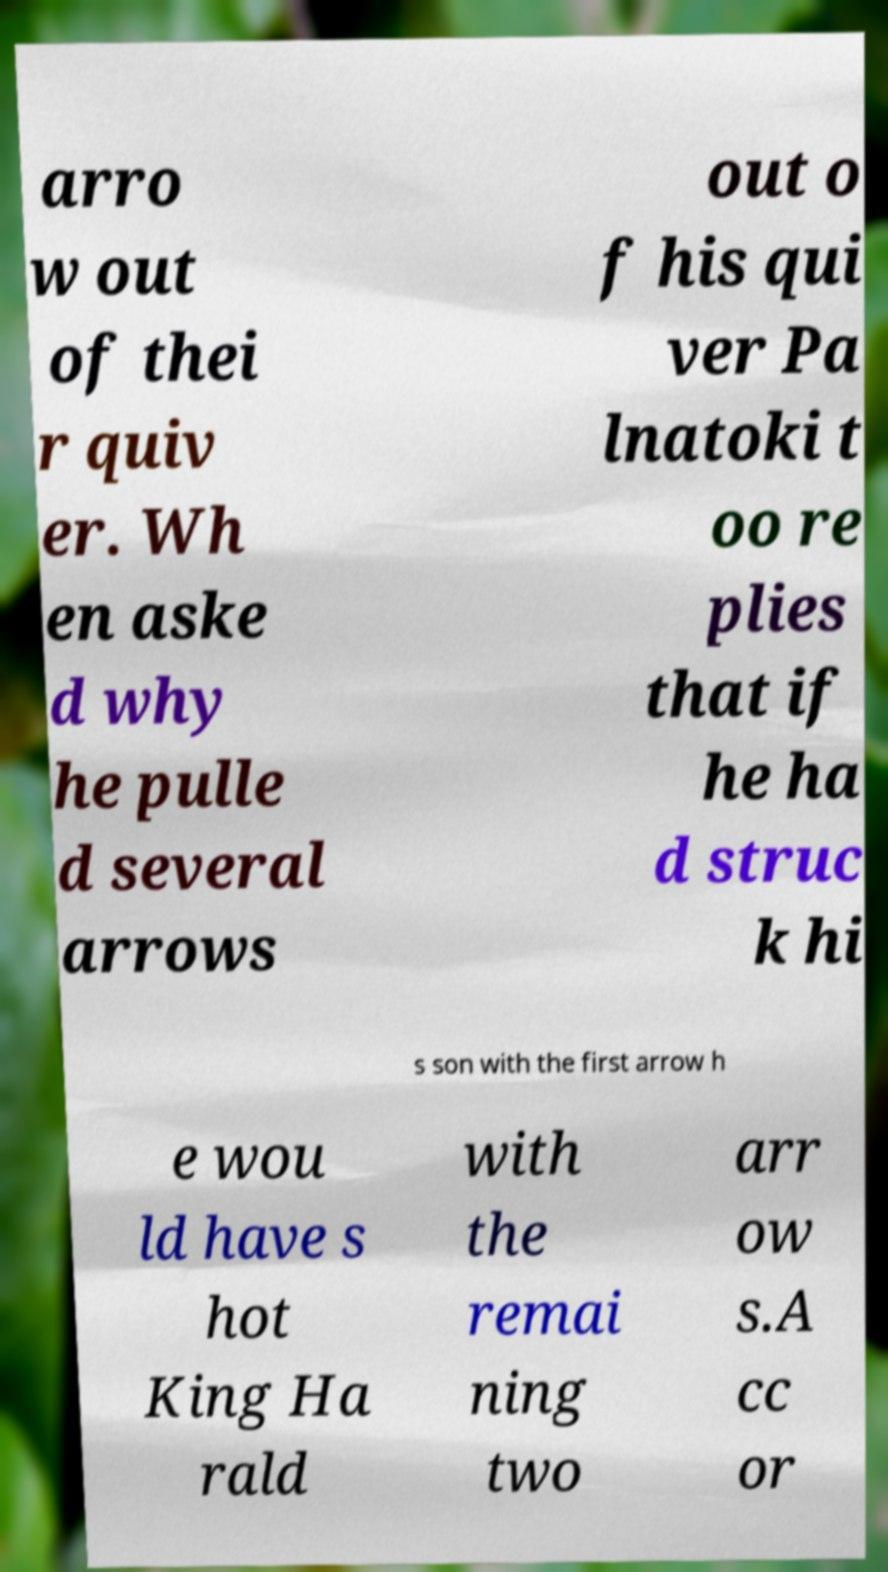For documentation purposes, I need the text within this image transcribed. Could you provide that? arro w out of thei r quiv er. Wh en aske d why he pulle d several arrows out o f his qui ver Pa lnatoki t oo re plies that if he ha d struc k hi s son with the first arrow h e wou ld have s hot King Ha rald with the remai ning two arr ow s.A cc or 